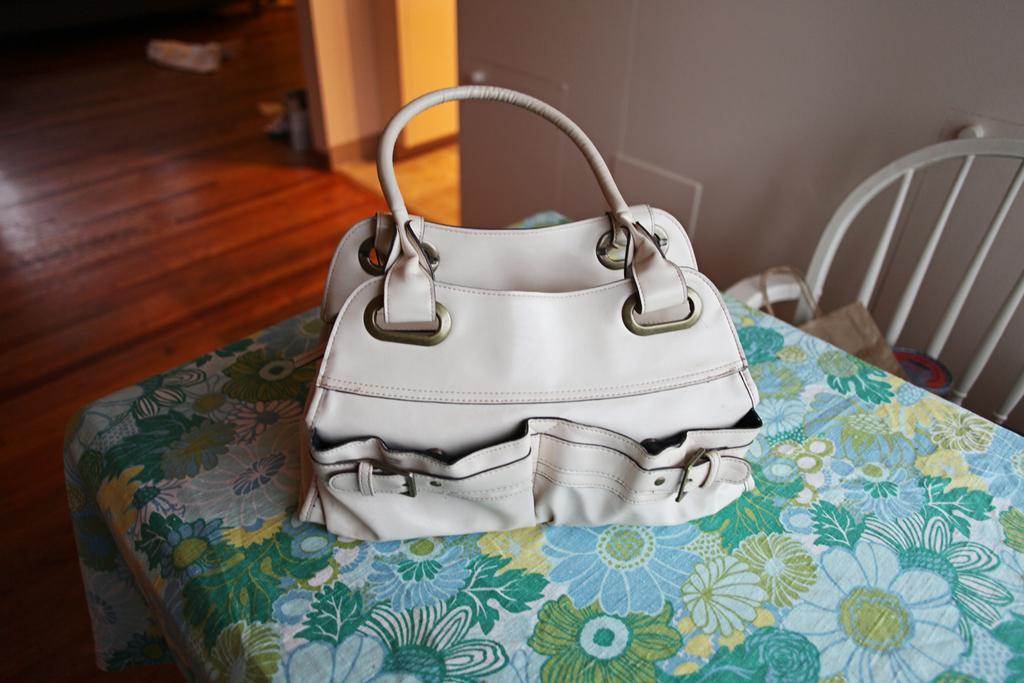Can you describe this image briefly? A hand bag is on the table beside it there is a chair. 